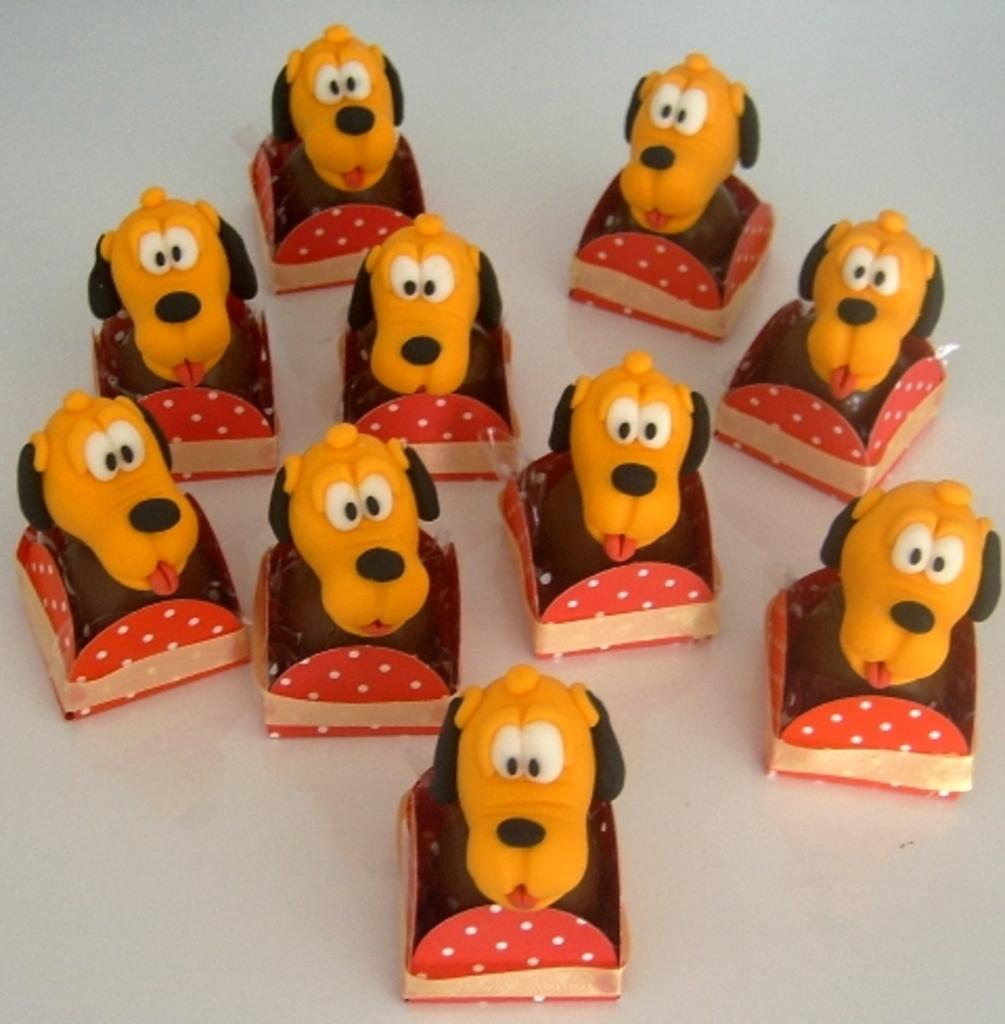What objects are present in the image? There are toys in the image. What is the color of the surface where the toys are placed? The surface on which the toys are placed is white. How many owls can be seen in the image? There are no owls present in the image. What type of insect is crawling on the toys in the image? There are no insects present in the image. 